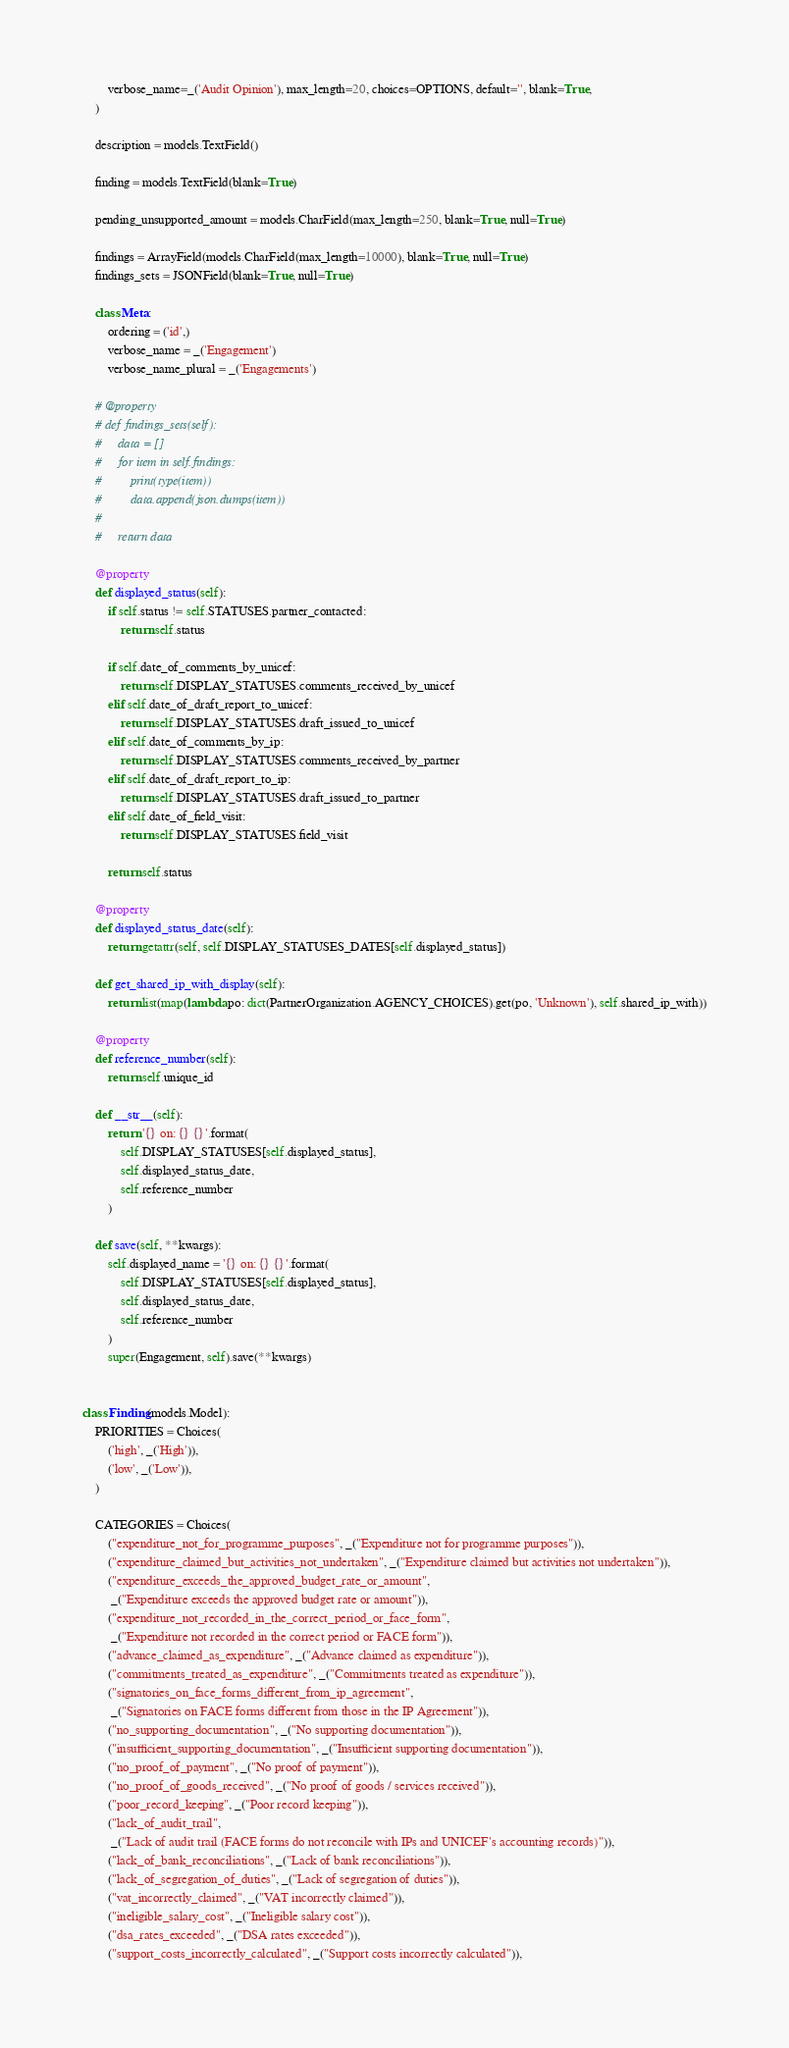Convert code to text. <code><loc_0><loc_0><loc_500><loc_500><_Python_>        verbose_name=_('Audit Opinion'), max_length=20, choices=OPTIONS, default='', blank=True,
    )

    description = models.TextField()

    finding = models.TextField(blank=True)

    pending_unsupported_amount = models.CharField(max_length=250, blank=True, null=True)

    findings = ArrayField(models.CharField(max_length=10000), blank=True, null=True)
    findings_sets = JSONField(blank=True, null=True)

    class Meta:
        ordering = ('id',)
        verbose_name = _('Engagement')
        verbose_name_plural = _('Engagements')

    # @property
    # def findings_sets(self):
    #     data = []
    #     for item in self.findings:
    #         print(type(item))
    #         data.append(json.dumps(item))
    #
    #     return data

    @property
    def displayed_status(self):
        if self.status != self.STATUSES.partner_contacted:
            return self.status

        if self.date_of_comments_by_unicef:
            return self.DISPLAY_STATUSES.comments_received_by_unicef
        elif self.date_of_draft_report_to_unicef:
            return self.DISPLAY_STATUSES.draft_issued_to_unicef
        elif self.date_of_comments_by_ip:
            return self.DISPLAY_STATUSES.comments_received_by_partner
        elif self.date_of_draft_report_to_ip:
            return self.DISPLAY_STATUSES.draft_issued_to_partner
        elif self.date_of_field_visit:
            return self.DISPLAY_STATUSES.field_visit

        return self.status

    @property
    def displayed_status_date(self):
        return getattr(self, self.DISPLAY_STATUSES_DATES[self.displayed_status])

    def get_shared_ip_with_display(self):
        return list(map(lambda po: dict(PartnerOrganization.AGENCY_CHOICES).get(po, 'Unknown'), self.shared_ip_with))

    @property
    def reference_number(self):
        return self.unique_id

    def __str__(self):
        return '{} on: {} {}'.format(
            self.DISPLAY_STATUSES[self.displayed_status],
            self.displayed_status_date,
            self.reference_number
        )

    def save(self, **kwargs):
        self.displayed_name = '{} on: {} {}'.format(
            self.DISPLAY_STATUSES[self.displayed_status],
            self.displayed_status_date,
            self.reference_number
        )
        super(Engagement, self).save(**kwargs)


class Finding(models.Model):
    PRIORITIES = Choices(
        ('high', _('High')),
        ('low', _('Low')),
    )

    CATEGORIES = Choices(
        ("expenditure_not_for_programme_purposes", _("Expenditure not for programme purposes")),
        ("expenditure_claimed_but_activities_not_undertaken", _("Expenditure claimed but activities not undertaken")),
        ("expenditure_exceeds_the_approved_budget_rate_or_amount",
         _("Expenditure exceeds the approved budget rate or amount")),
        ("expenditure_not_recorded_in_the_correct_period_or_face_form",
         _("Expenditure not recorded in the correct period or FACE form")),
        ("advance_claimed_as_expenditure", _("Advance claimed as expenditure")),
        ("commitments_treated_as_expenditure", _("Commitments treated as expenditure")),
        ("signatories_on_face_forms_different_from_ip_agreement",
         _("Signatories on FACE forms different from those in the IP Agreement")),
        ("no_supporting_documentation", _("No supporting documentation")),
        ("insufficient_supporting_documentation", _("Insufficient supporting documentation")),
        ("no_proof_of_payment", _("No proof of payment")),
        ("no_proof_of_goods_received", _("No proof of goods / services received")),
        ("poor_record_keeping", _("Poor record keeping")),
        ("lack_of_audit_trail",
         _("Lack of audit trail (FACE forms do not reconcile with IPs and UNICEF's accounting records)")),
        ("lack_of_bank_reconciliations", _("Lack of bank reconciliations")),
        ("lack_of_segregation_of_duties", _("Lack of segregation of duties")),
        ("vat_incorrectly_claimed", _("VAT incorrectly claimed")),
        ("ineligible_salary_cost", _("Ineligible salary cost")),
        ("dsa_rates_exceeded", _("DSA rates exceeded")),
        ("support_costs_incorrectly_calculated", _("Support costs incorrectly calculated")),</code> 